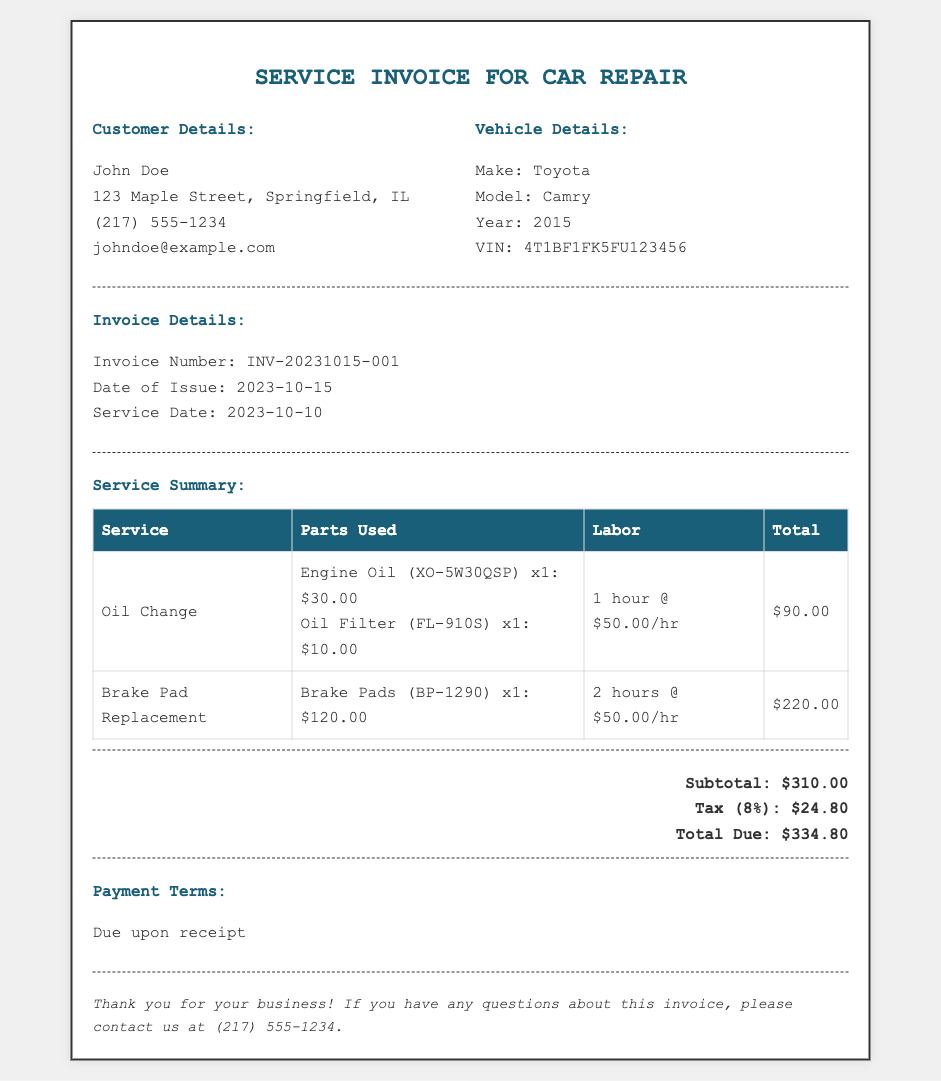What is the invoice number? The invoice number is listed under Invoice Details in the document, which is INV-20231015-001.
Answer: INV-20231015-001 Who is the customer? The customer's name is displayed in the Customer Details section of the document, which is John Doe.
Answer: John Doe What is the date of service? The date of service is provided under Invoice Details, which is 2023-10-10.
Answer: 2023-10-10 How many hours were billed for the Brake Pad Replacement? The labor hours for Brake Pad Replacement are shown in the Service Summary table, which states 2 hours.
Answer: 2 hours What is the subtotal amount? The subtotal is detailed in the total section of the invoice, which is $310.00.
Answer: $310.00 What parts were used for the Oil Change? The parts for the Oil Change are listed in the Service Summary table, which are Engine Oil (XO-5W30QSP) and Oil Filter (FL-910S).
Answer: Engine Oil (XO-5W30QSP) and Oil Filter (FL-910S) What is the total due after tax? The total due amount is stated at the end of the document, which includes the subtotal and tax, totaling $334.80.
Answer: $334.80 